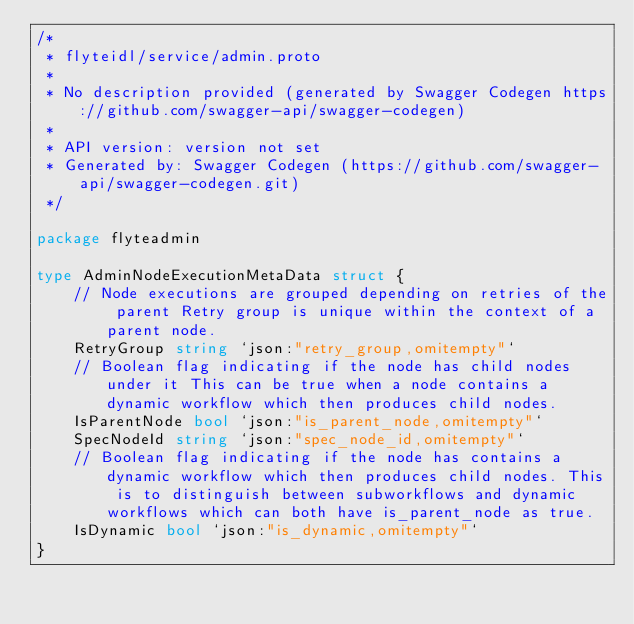Convert code to text. <code><loc_0><loc_0><loc_500><loc_500><_Go_>/*
 * flyteidl/service/admin.proto
 *
 * No description provided (generated by Swagger Codegen https://github.com/swagger-api/swagger-codegen)
 *
 * API version: version not set
 * Generated by: Swagger Codegen (https://github.com/swagger-api/swagger-codegen.git)
 */

package flyteadmin

type AdminNodeExecutionMetaData struct {
	// Node executions are grouped depending on retries of the parent Retry group is unique within the context of a parent node.
	RetryGroup string `json:"retry_group,omitempty"`
	// Boolean flag indicating if the node has child nodes under it This can be true when a node contains a dynamic workflow which then produces child nodes.
	IsParentNode bool `json:"is_parent_node,omitempty"`
	SpecNodeId string `json:"spec_node_id,omitempty"`
	// Boolean flag indicating if the node has contains a dynamic workflow which then produces child nodes. This is to distinguish between subworkflows and dynamic workflows which can both have is_parent_node as true.
	IsDynamic bool `json:"is_dynamic,omitempty"`
}
</code> 